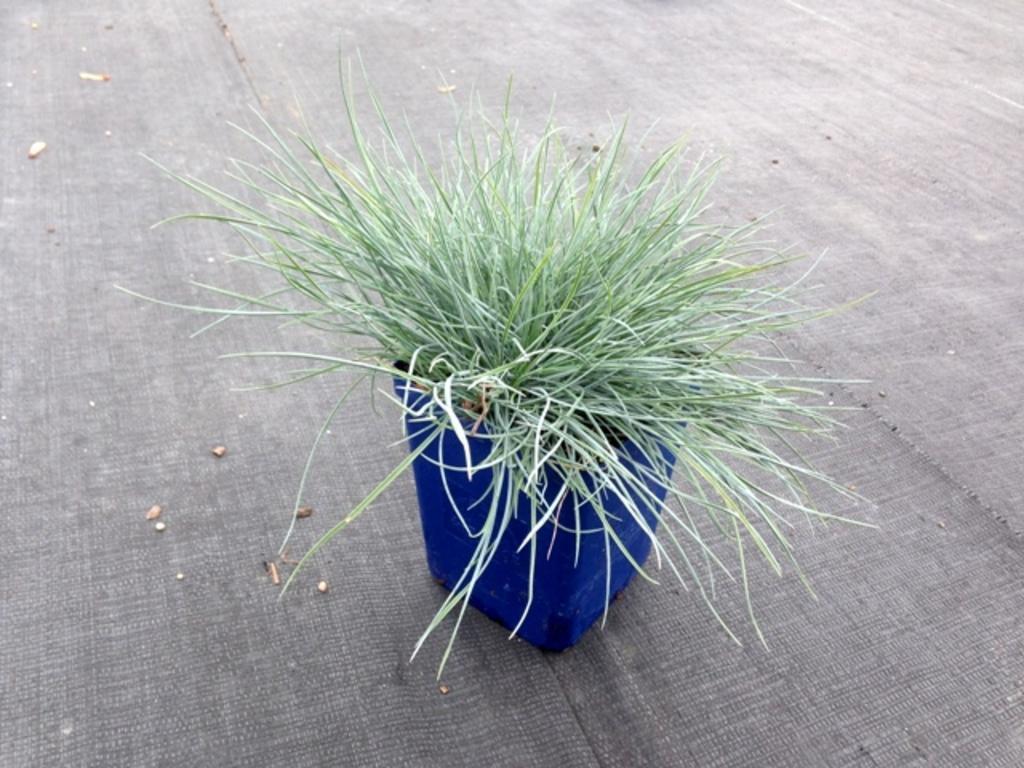How would you summarize this image in a sentence or two? In this image I can see a plant in a blue colour pot. I can also see few things on the surface. 